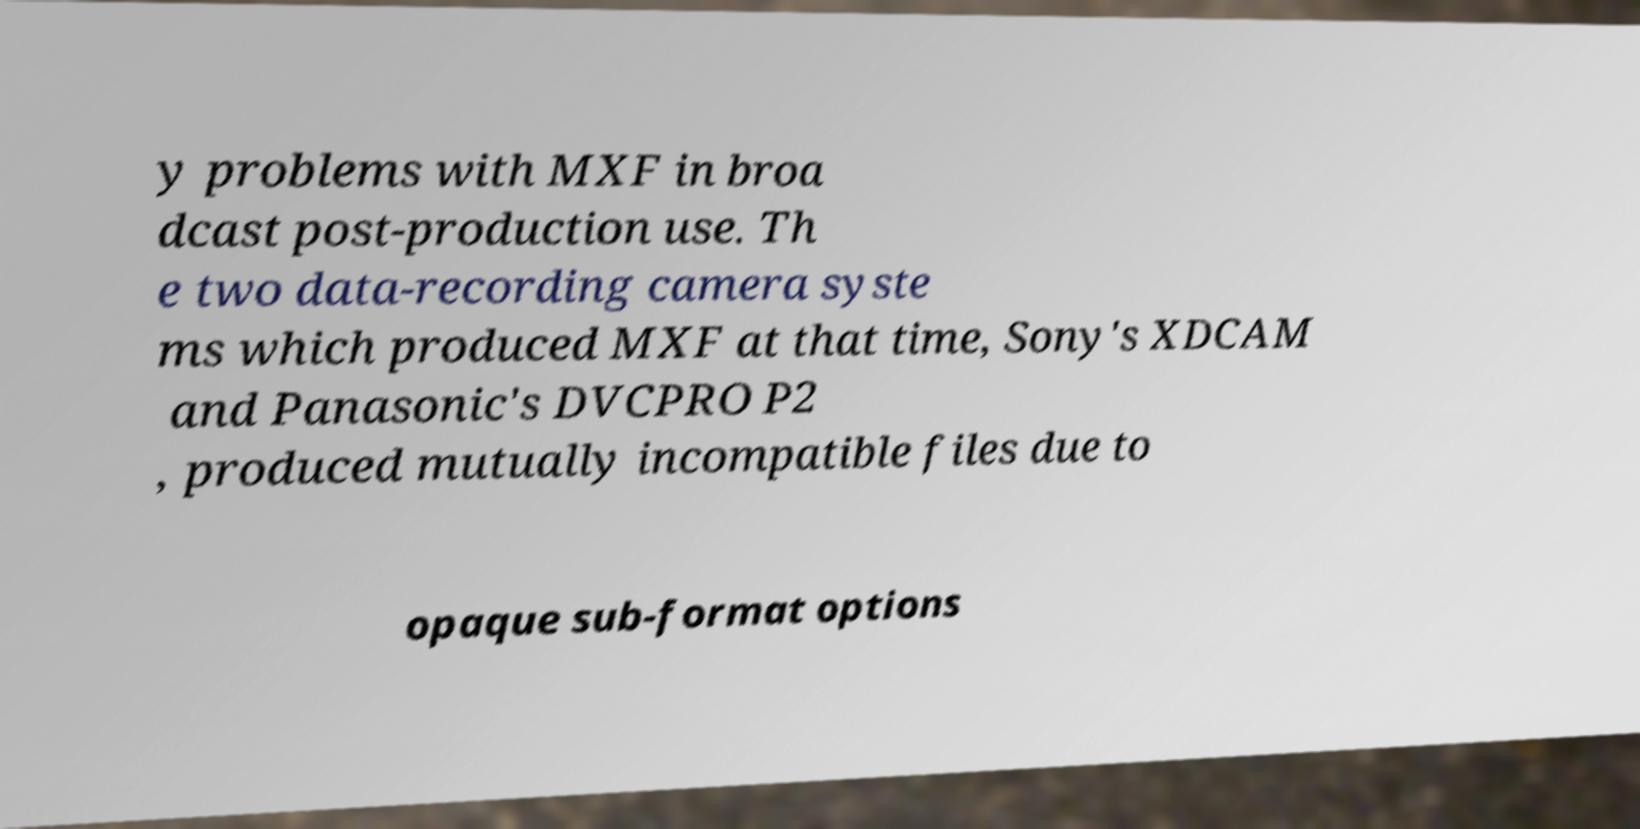There's text embedded in this image that I need extracted. Can you transcribe it verbatim? y problems with MXF in broa dcast post-production use. Th e two data-recording camera syste ms which produced MXF at that time, Sony's XDCAM and Panasonic's DVCPRO P2 , produced mutually incompatible files due to opaque sub-format options 